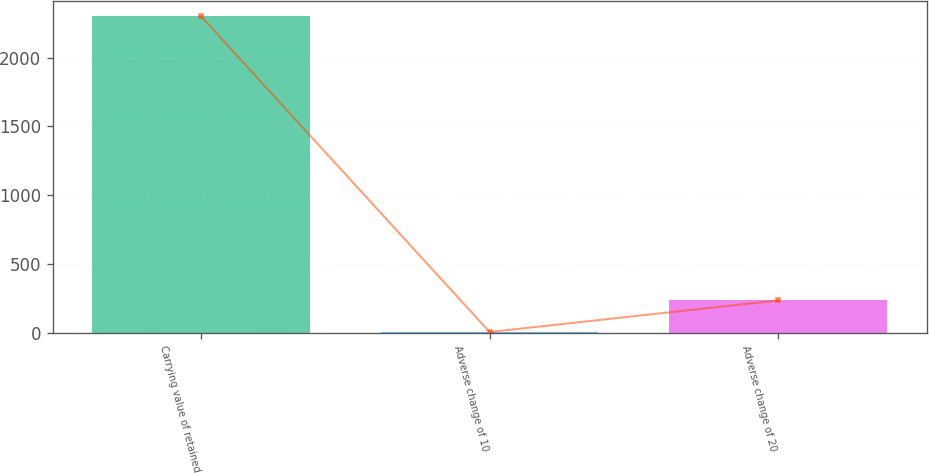Convert chart. <chart><loc_0><loc_0><loc_500><loc_500><bar_chart><fcel>Carrying value of retained<fcel>Adverse change of 10<fcel>Adverse change of 20<nl><fcel>2299<fcel>5<fcel>234.4<nl></chart> 